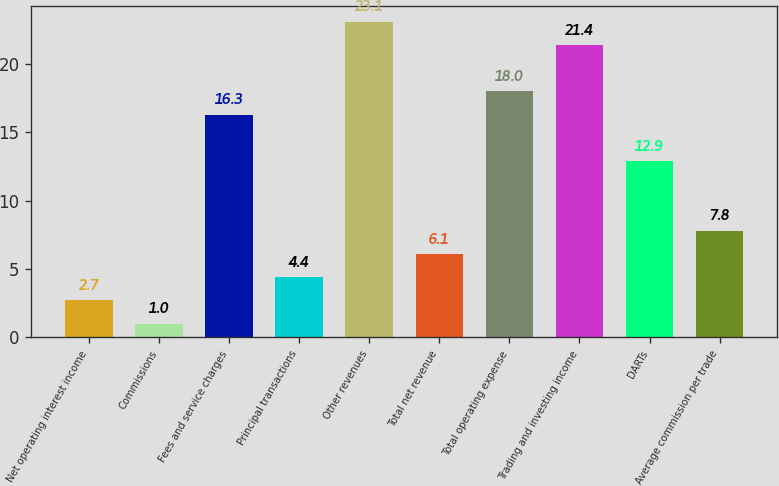Convert chart to OTSL. <chart><loc_0><loc_0><loc_500><loc_500><bar_chart><fcel>Net operating interest income<fcel>Commissions<fcel>Fees and service charges<fcel>Principal transactions<fcel>Other revenues<fcel>Total net revenue<fcel>Total operating expense<fcel>Trading and investing income<fcel>DARTs<fcel>Average commission per trade<nl><fcel>2.7<fcel>1<fcel>16.3<fcel>4.4<fcel>23.1<fcel>6.1<fcel>18<fcel>21.4<fcel>12.9<fcel>7.8<nl></chart> 